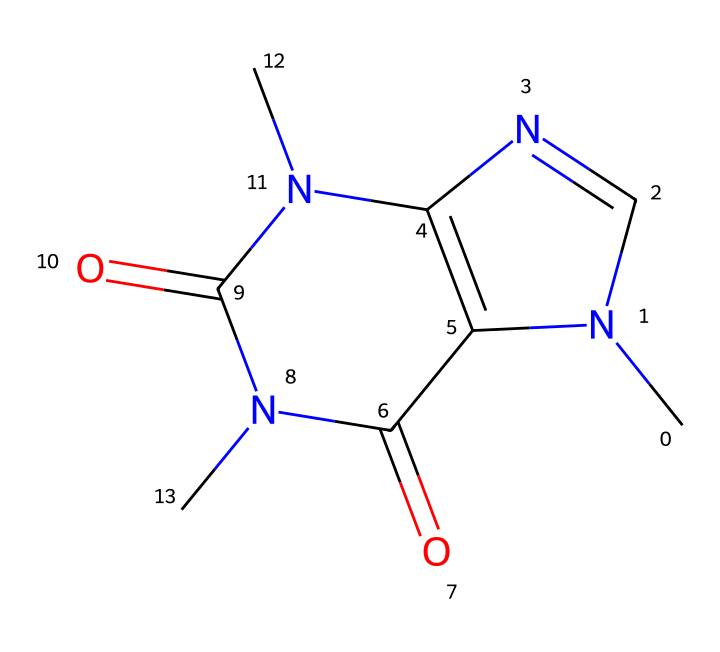how many carbon atoms are in the caffeine structure? To find the number of carbon atoms, we can analyze the SMILES representation. In CN1C=NC2=C1C(=O)N(C(=O)N2C), we count the 'C' characters present in the structure. There are a total of 8 instances of 'C' in the SMILES.
Answer: 8 how many nitrogen atoms are present in caffeine? By examining the SMILES representation, we can count the occurrences of 'N'. The SMILES shows three 'N' characters, indicating there are three nitrogen atoms in the structure.
Answer: 4 is caffeine an organic or inorganic compound? Caffeine contains carbon and is made primarily from organic molecules such as rings and carbon chains. Thus, caffeine is classified as an organic compound.
Answer: organic what molecular structure does caffeine represent? Caffeine has a complex heterocyclic structure consisting of nitrogen atoms within a bicyclic framework. This arrangement is typical for alkaloids, which caffeine is classified under.
Answer: alkaloid which bond type is prevalent in the structure of caffeine? The caffeine structure features predominantly covalent bonds, which are formed by the sharing of electrons between the carbon and nitrogen atoms. These atoms share electrons to achieve stability.
Answer: covalent how many rings are present in the caffeine molecule? The caffeine structure contains two interconnected rings (a bicyclic structure). We can identify the cyclic patterns from the 'C' and 'N' connections in the SMILES representation.
Answer: 2 